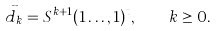Convert formula to latex. <formula><loc_0><loc_0><loc_500><loc_500>\vec { d } _ { k } = S ^ { k + 1 } ( 1 \dots , 1 ) ^ { t } , \quad k \geq 0 .</formula> 